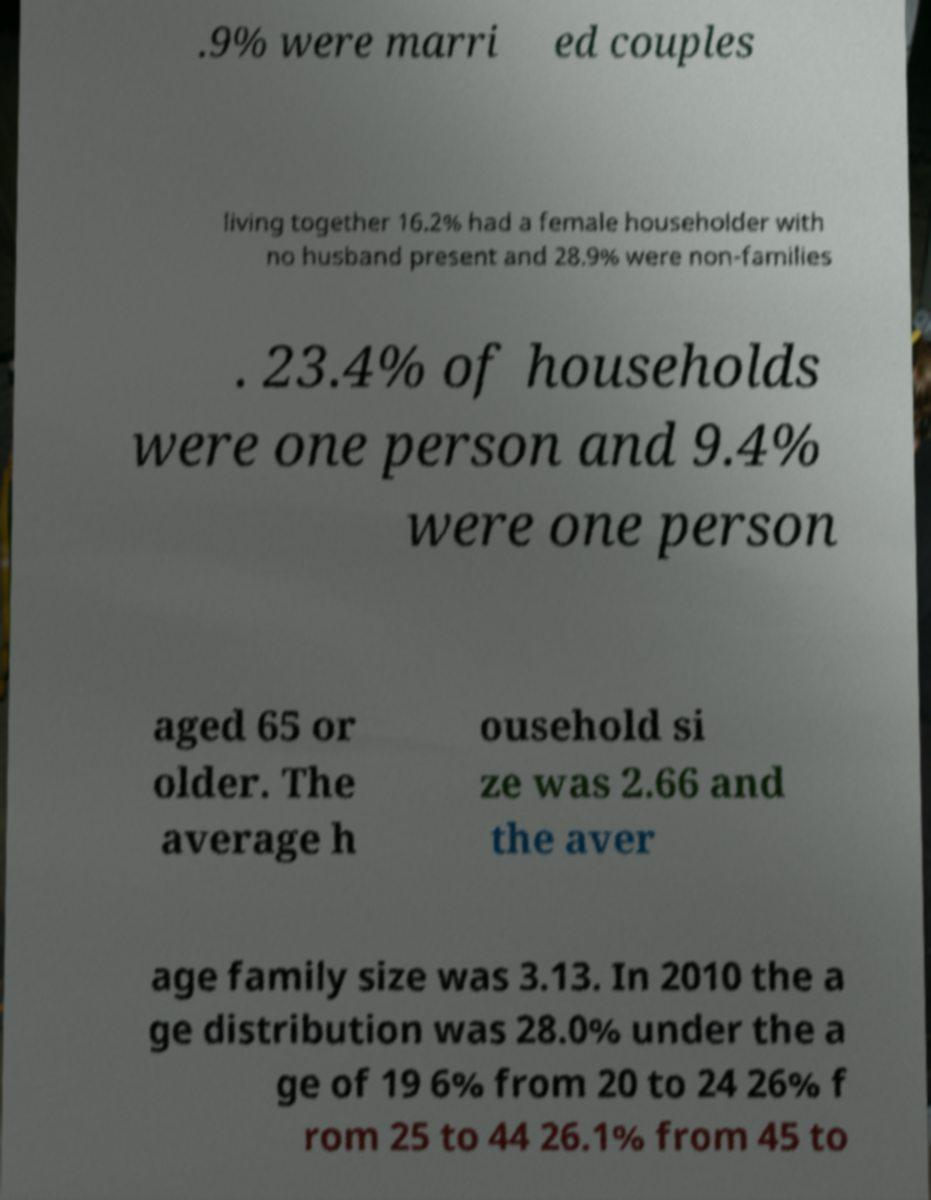There's text embedded in this image that I need extracted. Can you transcribe it verbatim? .9% were marri ed couples living together 16.2% had a female householder with no husband present and 28.9% were non-families . 23.4% of households were one person and 9.4% were one person aged 65 or older. The average h ousehold si ze was 2.66 and the aver age family size was 3.13. In 2010 the a ge distribution was 28.0% under the a ge of 19 6% from 20 to 24 26% f rom 25 to 44 26.1% from 45 to 